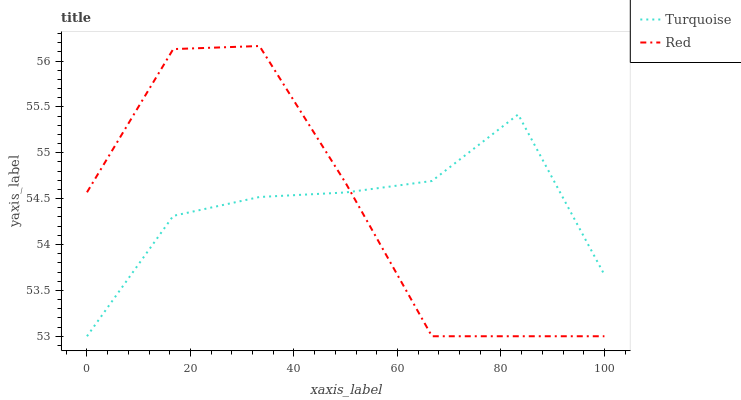Does Red have the minimum area under the curve?
Answer yes or no. Yes. Does Turquoise have the maximum area under the curve?
Answer yes or no. Yes. Does Red have the maximum area under the curve?
Answer yes or no. No. Is Turquoise the smoothest?
Answer yes or no. Yes. Is Red the roughest?
Answer yes or no. Yes. Is Red the smoothest?
Answer yes or no. No. Does Turquoise have the lowest value?
Answer yes or no. Yes. Does Red have the highest value?
Answer yes or no. Yes. Does Red intersect Turquoise?
Answer yes or no. Yes. Is Red less than Turquoise?
Answer yes or no. No. Is Red greater than Turquoise?
Answer yes or no. No. 